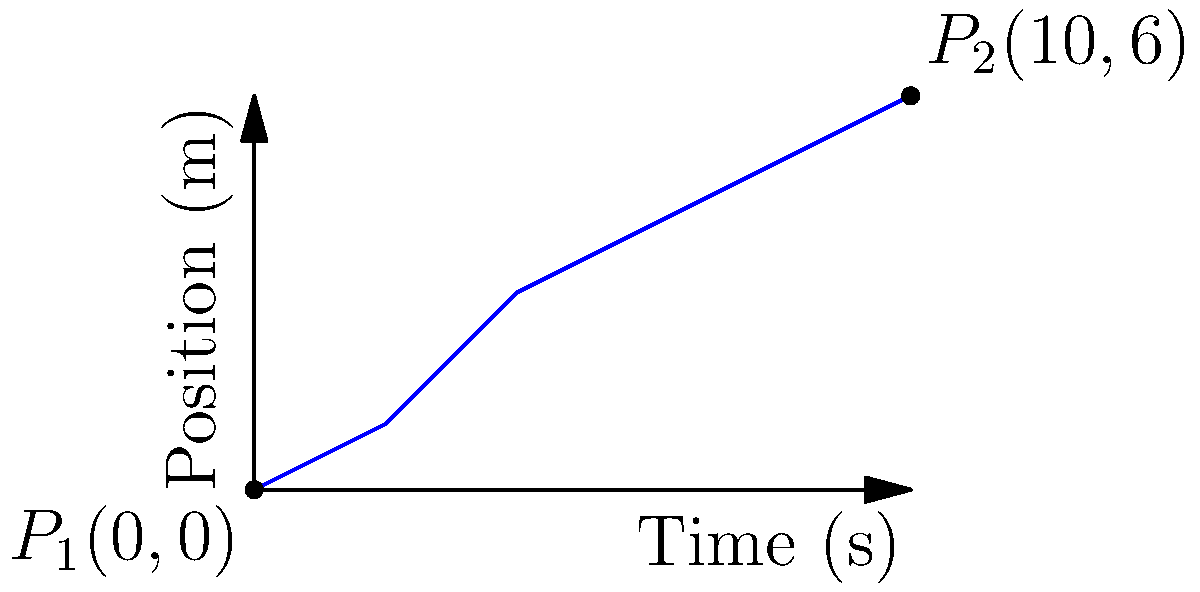During a practice session, you pass a basketball to your teammate. The graph shows the position of the ball over time. Given that the initial position $P_1$ is $(0,0)$ and the final position $P_2$ is $(10,6)$, determine the velocity vector of the basketball. To find the velocity vector, we need to follow these steps:

1) The velocity vector is given by the displacement vector divided by the time taken:
   
   $\vec{v} = \frac{\Delta \vec{r}}{\Delta t}$

2) Calculate the displacement vector:
   $\Delta \vec{r} = P_2 - P_1 = (10,6) - (0,0) = (10,6)$

3) Calculate the time taken:
   $\Delta t = 10 - 0 = 10$ seconds

4) Now, we can calculate the velocity vector:
   
   $\vec{v} = \frac{(10,6)}{10} = (1,0.6)$

5) This means the horizontal component of velocity is 1 m/s and the vertical component is 0.6 m/s.

Therefore, the velocity vector of the basketball is $(1,0.6)$ m/s.
Answer: $(1,0.6)$ m/s 